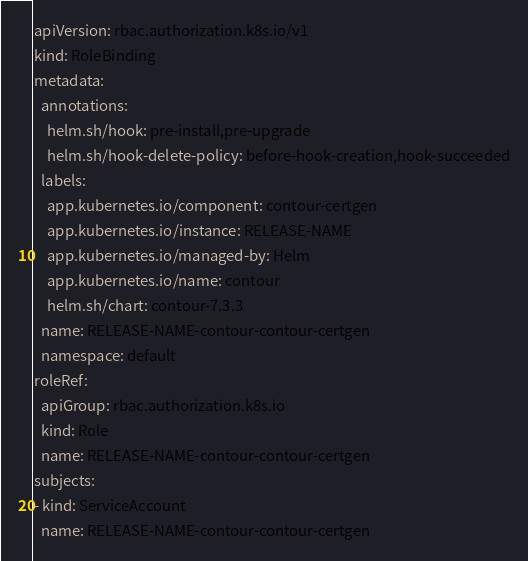<code> <loc_0><loc_0><loc_500><loc_500><_YAML_>apiVersion: rbac.authorization.k8s.io/v1
kind: RoleBinding
metadata:
  annotations:
    helm.sh/hook: pre-install,pre-upgrade
    helm.sh/hook-delete-policy: before-hook-creation,hook-succeeded
  labels:
    app.kubernetes.io/component: contour-certgen
    app.kubernetes.io/instance: RELEASE-NAME
    app.kubernetes.io/managed-by: Helm
    app.kubernetes.io/name: contour
    helm.sh/chart: contour-7.3.3
  name: RELEASE-NAME-contour-contour-certgen
  namespace: default
roleRef:
  apiGroup: rbac.authorization.k8s.io
  kind: Role
  name: RELEASE-NAME-contour-contour-certgen
subjects:
- kind: ServiceAccount
  name: RELEASE-NAME-contour-contour-certgen
</code> 